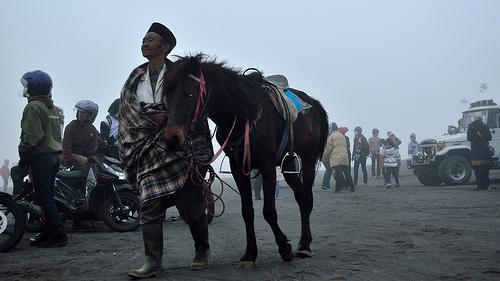How many horses are there?
Give a very brief answer. 1. 